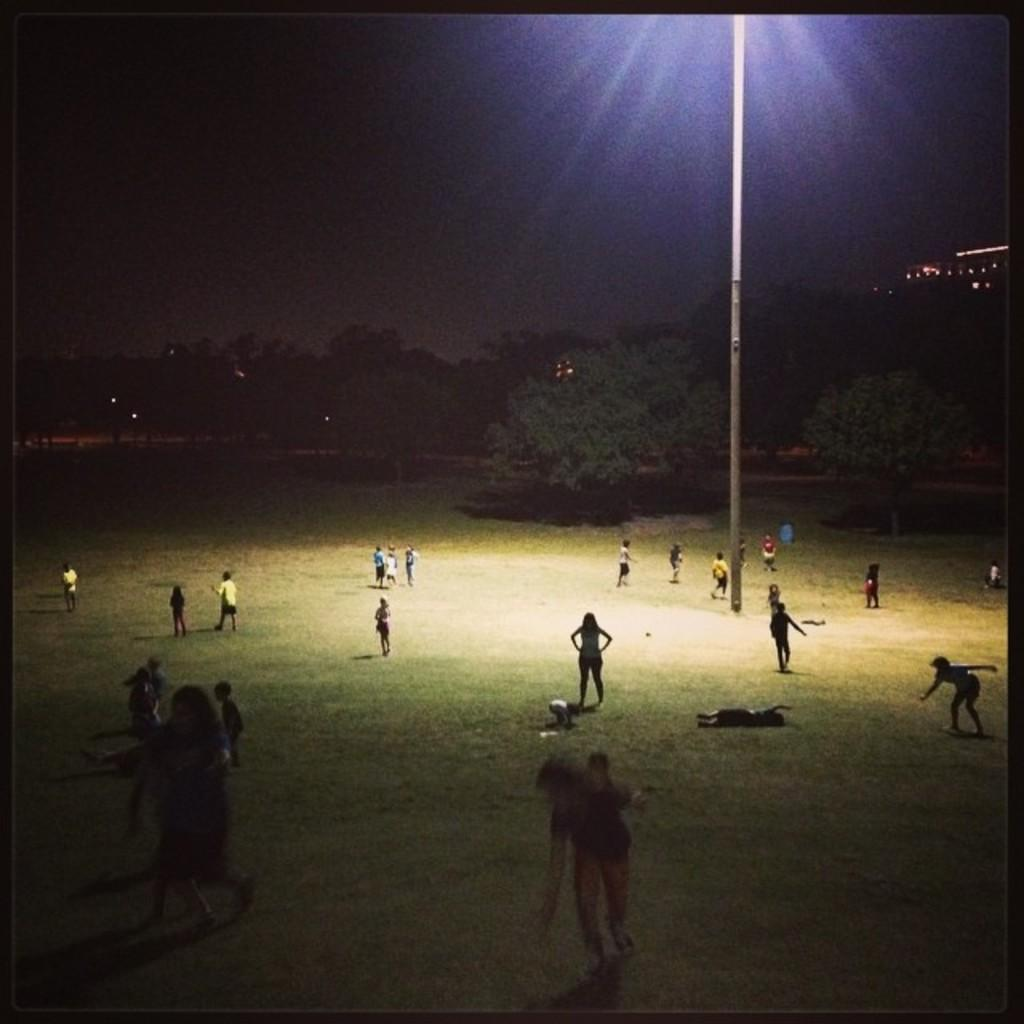What are the children in the image doing? There are boys and girls playing in the image. Where are the children playing? The playing is taking place on a ground. What can be seen in the background of the image? There are trees visible in the background of the image. What is the tall structure in the image? There is a tall light pole in the image. What type of quince is being used as a ball in the image? There is no quince present in the image, and the children are not using any fruit as a ball. How many rings can be seen on the fingers of the children in the image? There are no rings visible on the fingers of the children in the image. 